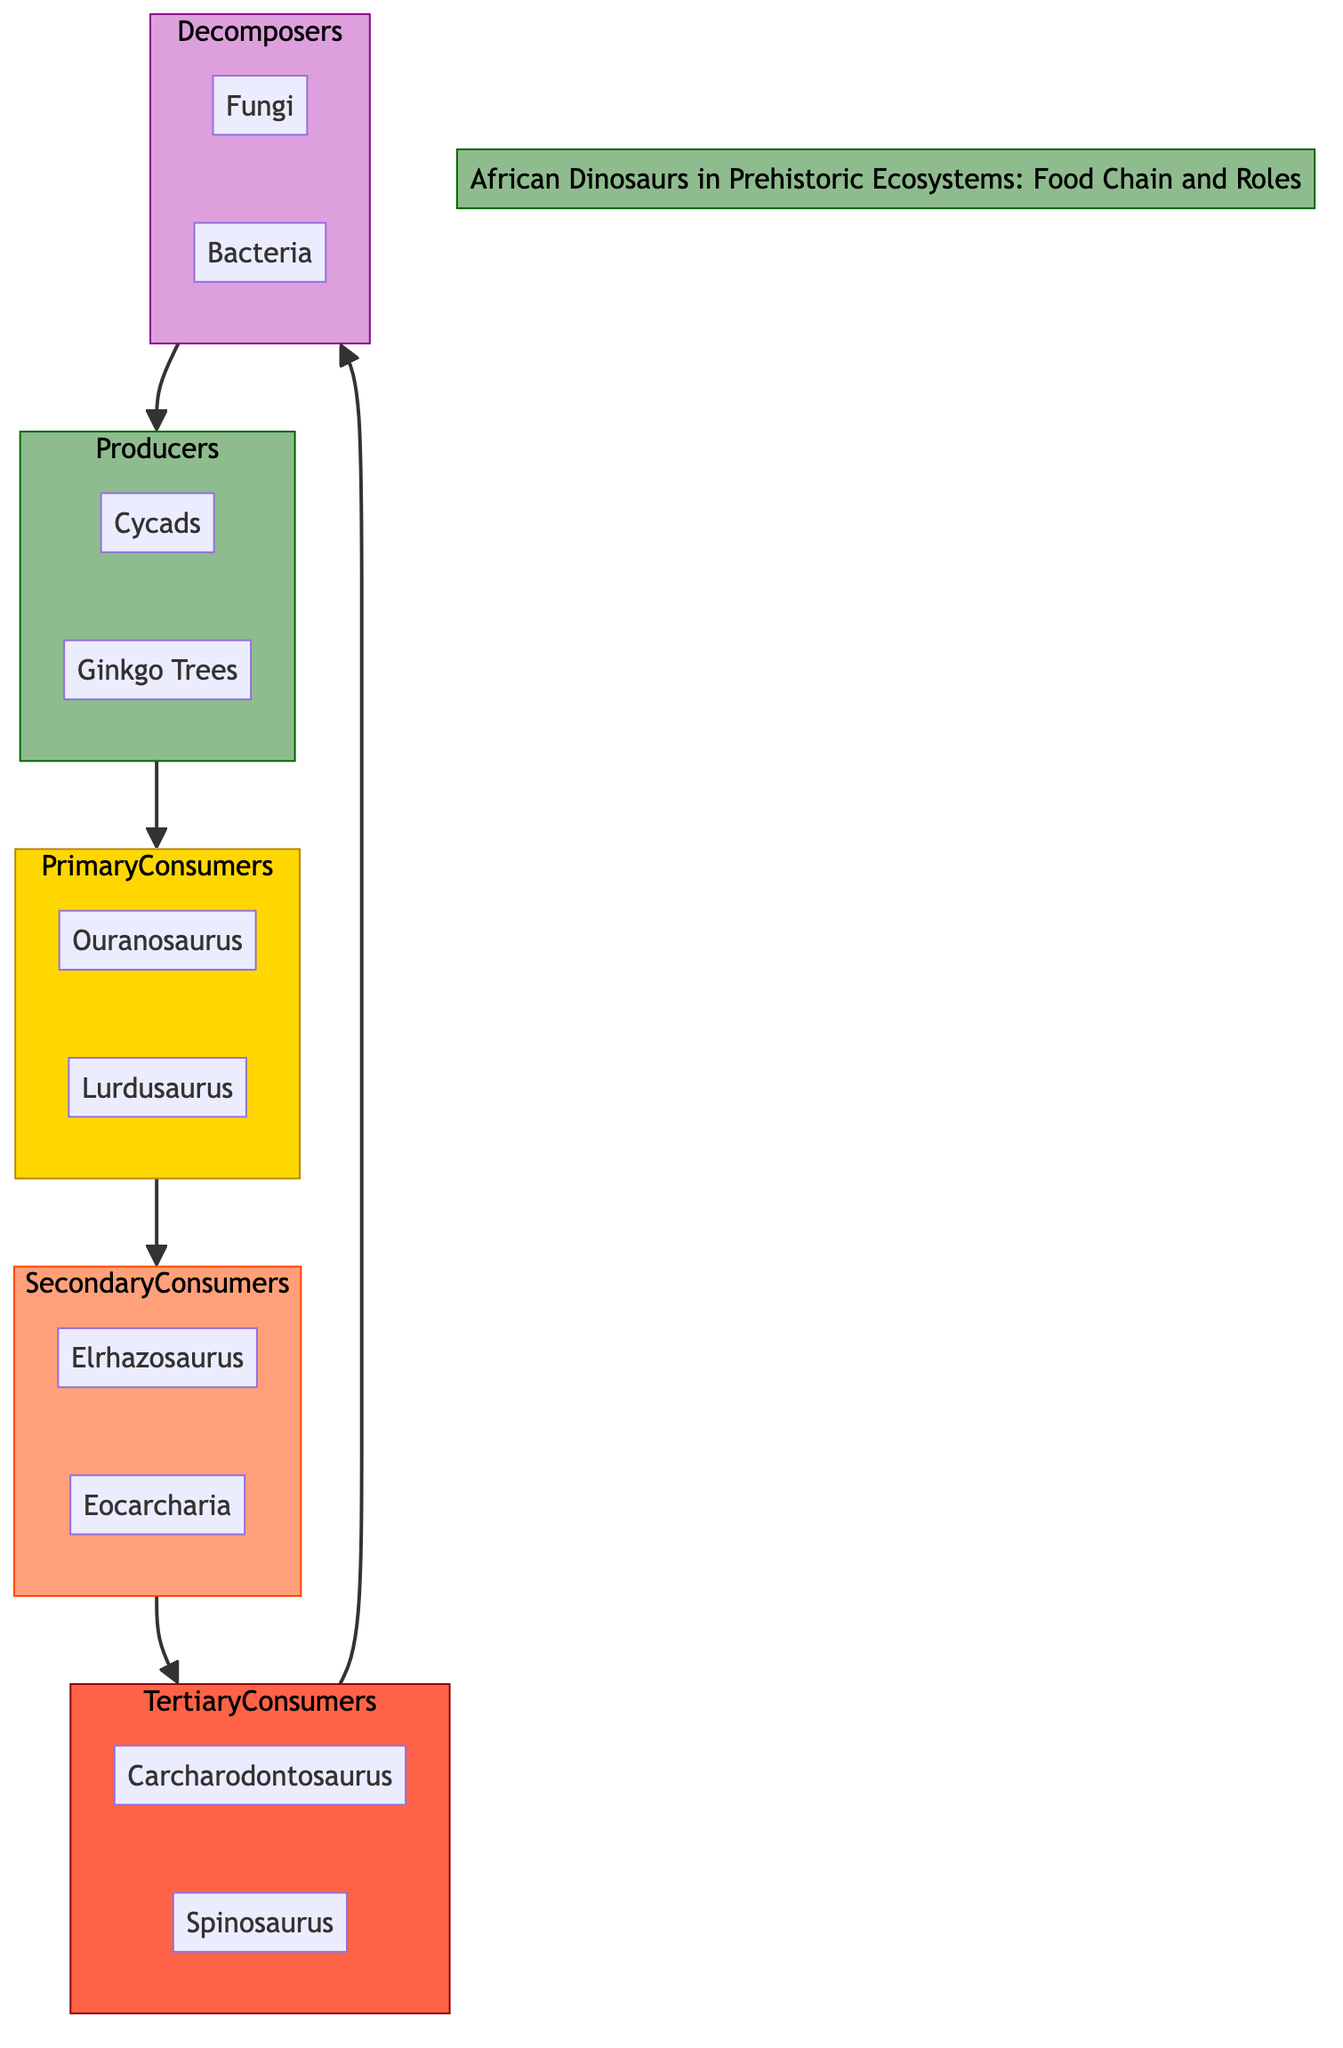What are the two producers listed in the diagram? The diagram directly lists two producers: Cycads and Ginkgo Trees under the Producers section.
Answer: Cycads, Ginkgo Trees How many primary consumers are there? The diagram shows two nodes under the Primary Consumers section: Ouranosaurus and Lurdusaurus, indicating there are two primary consumers.
Answer: 2 Which dinosaur is a tertiary consumer? Carcharodontosaurus and Spinosaurus are both listed as tertiary consumers in the Tertiary Consumers section of the diagram.
Answer: Carcharodontosaurus What type of organisms are represented as decomposers? The diagram identifies Fungi and Bacteria as the decomposers in the Decomposers section.
Answer: Fungi, Bacteria Which consumer type feeds on both small herbivores and insects? Elrhazosaurus is described in the Secondary Consumers section as feeding on insects and smaller reptiles, which includes small herbivores.
Answer: Elrhazosaurus Which group does Ouranosaurus belong to? Ouranosaurus is listed under the Primary Consumers section, indicating it is a primary consumer.
Answer: Primary Consumers How do tertiary consumers interact with decomposers in the flow? Tertiary Consumers (Carcharodontosaurus and Spinosaurus) lead directly to Decomposers, indicating that their consumption results in organic matter that decomposers break down, hence showing the cyclical nature of the ecosystem.
Answer: Directly What is the role of decomposers in the ecosystem as depicted in the diagram? The diagram indicates that decomposers, such as Fungi and Bacteria, recycle nutrients back into the ecosystem by breaking down organic matter from dead plants and animals, signifying their role in nutrient cycling.
Answer: Recycle nutrients What color represents primary consumers in the diagram? The color designated for Primary Consumers, as defined in the diagram, is represented as fill color #FFD700 (gold), indicating its unique visual distinction.
Answer: Gold 